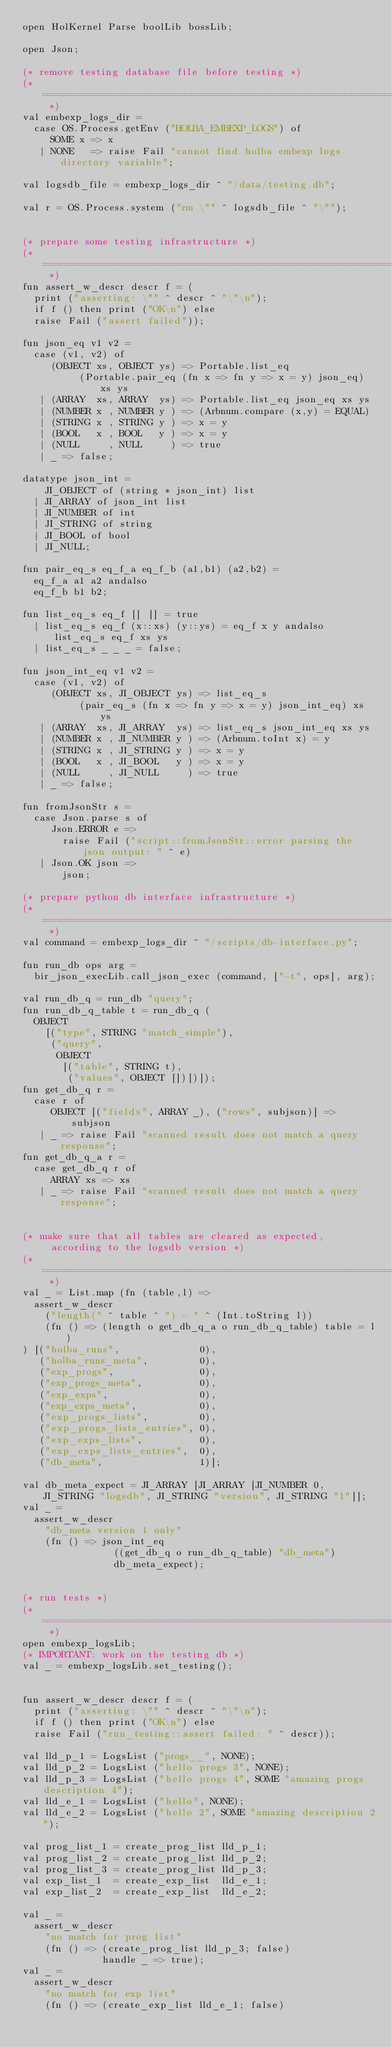Convert code to text. <code><loc_0><loc_0><loc_500><loc_500><_SML_>open HolKernel Parse boolLib bossLib;

open Json;

(* remove testing database file before testing *)
(* ======================================================================= *)
val embexp_logs_dir =
  case OS.Process.getEnv ("HOLBA_EMBEXP_LOGS") of
     SOME x => x
   | NONE   => raise Fail "cannot find holba embexp logs directory variable";

val logsdb_file = embexp_logs_dir ^ "/data/testing.db";

val r = OS.Process.system ("rm \"" ^ logsdb_file ^ "\"");


(* prepare some testing infrastructure *)
(* ======================================================================= *)
fun assert_w_descr descr f = (
  print ("asserting: \"" ^ descr ^ "\"\n");
  if f () then print ("OK\n") else
  raise Fail ("assert failed"));

fun json_eq v1 v2 =
  case (v1, v2) of
     (OBJECT xs, OBJECT ys) => Portable.list_eq
          (Portable.pair_eq (fn x => fn y => x = y) json_eq) xs ys
   | (ARRAY  xs, ARRAY  ys) => Portable.list_eq json_eq xs ys
   | (NUMBER x , NUMBER y ) => (Arbnum.compare (x,y) = EQUAL)
   | (STRING x , STRING y ) => x = y
   | (BOOL   x , BOOL   y ) => x = y
   | (NULL     , NULL     ) => true
   | _ => false;

datatype json_int =
    JI_OBJECT of (string * json_int) list
  | JI_ARRAY of json_int list
  | JI_NUMBER of int
  | JI_STRING of string
  | JI_BOOL of bool
  | JI_NULL;

fun pair_eq_s eq_f_a eq_f_b (a1,b1) (a2,b2) =
  eq_f_a a1 a2 andalso
  eq_f_b b1 b2;

fun list_eq_s eq_f [] [] = true
  | list_eq_s eq_f (x::xs) (y::ys) = eq_f x y andalso list_eq_s eq_f xs ys
  | list_eq_s _ _ _ = false;

fun json_int_eq v1 v2 =
  case (v1, v2) of
     (OBJECT xs, JI_OBJECT ys) => list_eq_s
          (pair_eq_s (fn x => fn y => x = y) json_int_eq) xs ys
   | (ARRAY  xs, JI_ARRAY  ys) => list_eq_s json_int_eq xs ys
   | (NUMBER x , JI_NUMBER y ) => (Arbnum.toInt x) = y
   | (STRING x , JI_STRING y ) => x = y
   | (BOOL   x , JI_BOOL   y ) => x = y
   | (NULL     , JI_NULL     ) => true
   | _ => false;

fun fromJsonStr s =
  case Json.parse s of
     Json.ERROR e =>
       raise Fail ("script::fromJsonStr::error parsing the json output: " ^ e)
   | Json.OK json =>
       json;

(* prepare python db interface infrastructure *)
(* ======================================================================= *)
val command = embexp_logs_dir ^ "/scripts/db-interface.py";

fun run_db ops arg =
  bir_json_execLib.call_json_exec (command, ["-t", ops], arg);

val run_db_q = run_db "query";
fun run_db_q_table t = run_db_q (
  OBJECT
    [("type", STRING "match_simple"),
     ("query",
      OBJECT
       [("table", STRING t),
        ("values", OBJECT [])])]);
fun get_db_q r =
  case r of
     OBJECT [("fields", ARRAY _), ("rows", subjson)] => subjson
   | _ => raise Fail "scanned result does not match a query response";
fun get_db_q_a r =
  case get_db_q r of
     ARRAY xs => xs
   | _ => raise Fail "scanned result does not match a query response";


(* make sure that all tables are cleared as expected,
     according to the logsdb version *)
(* ======================================================================= *)
val _ = List.map (fn (table,l) =>
  assert_w_descr
    ("length(" ^ table ^ ") = " ^ (Int.toString l))
    (fn () => (length o get_db_q_a o run_db_q_table) table = l)
) [("holba_runs",              0),
   ("holba_runs_meta",         0),
   ("exp_progs",               0),
   ("exp_progs_meta",          0),
   ("exp_exps",                0),
   ("exp_exps_meta",           0),
   ("exp_progs_lists",         0),
   ("exp_progs_lists_entries", 0),
   ("exp_exps_lists",          0),
   ("exp_exps_lists_entries",  0),
   ("db_meta",                 1)];

val db_meta_expect = JI_ARRAY [JI_ARRAY [JI_NUMBER 0, JI_STRING "logsdb", JI_STRING "version", JI_STRING "1"]];
val _ =
  assert_w_descr
    "db_meta version 1 only"
    (fn () => json_int_eq
                ((get_db_q o run_db_q_table) "db_meta")
                db_meta_expect);


(* run tests *)
(* ======================================================================= *)
open embexp_logsLib;
(* IMPORTANT: work on the testing db *)
val _ = embexp_logsLib.set_testing();


fun assert_w_descr descr f = (
  print ("asserting: \"" ^ descr ^ "\"\n");
  if f () then print ("OK\n") else
  raise Fail ("run_testing::assert failed: " ^ descr));

val lld_p_1 = LogsList ("progs__", NONE);
val lld_p_2 = LogsList ("hello progs 3", NONE);
val lld_p_3 = LogsList ("hello progs 4", SOME "amazing progs description 4");
val lld_e_1 = LogsList ("hello", NONE);
val lld_e_2 = LogsList ("hello 2", SOME "amazing description 2");

val prog_list_1 = create_prog_list lld_p_1;
val prog_list_2 = create_prog_list lld_p_2;
val prog_list_3 = create_prog_list lld_p_3;
val exp_list_1  = create_exp_list  lld_e_1;
val exp_list_2  = create_exp_list  lld_e_2;

val _ =
  assert_w_descr
    "no match for prog list"
    (fn () => (create_prog_list lld_p_3; false)
              handle _ => true);
val _ =
  assert_w_descr
    "no match for exp list"
    (fn () => (create_exp_list lld_e_1; false)</code> 